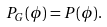<formula> <loc_0><loc_0><loc_500><loc_500>P _ { G } ( \phi ) = P ( \phi ) .</formula> 